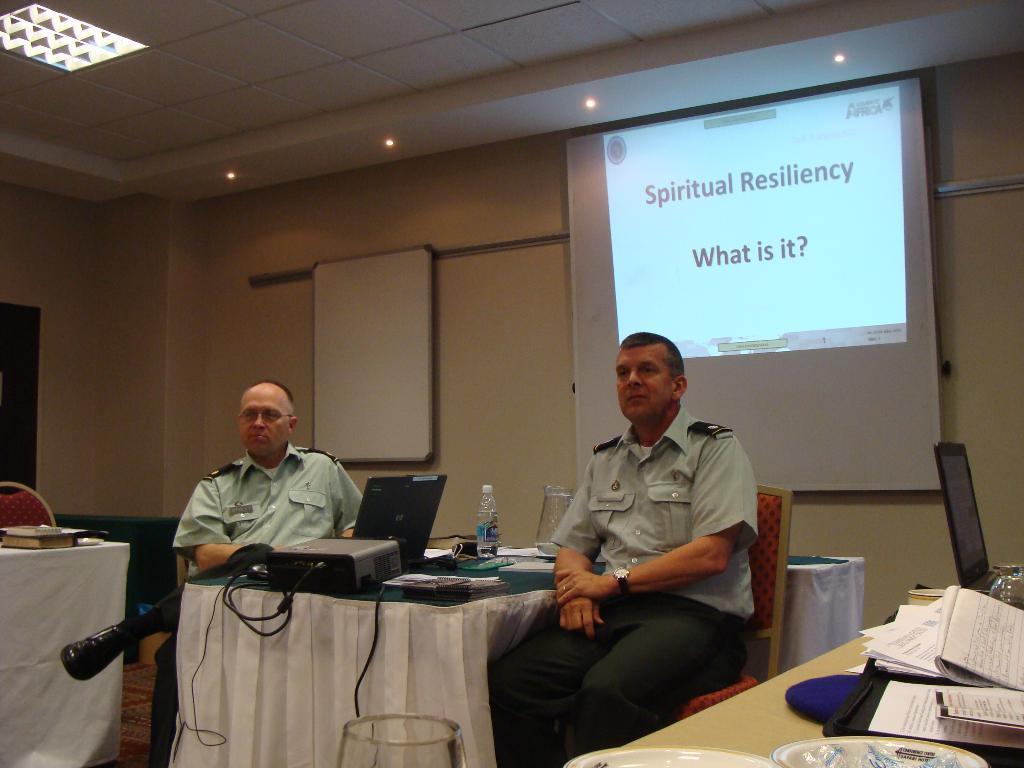Could you give a brief overview of what you see in this image? This image is clicked in conference room. There is a screen. on the left side two people are sitting on chair between them there is a table on that table there is a laptop ,projector machine ,bottle ,papers and the cloth on that. There are tables around them ,there is a table in the bottom right corner, on that table there are papers, books, there lights on the top left corner. There is a book left side on that table. Both men they are wearing grey color shirt and black color pant. 